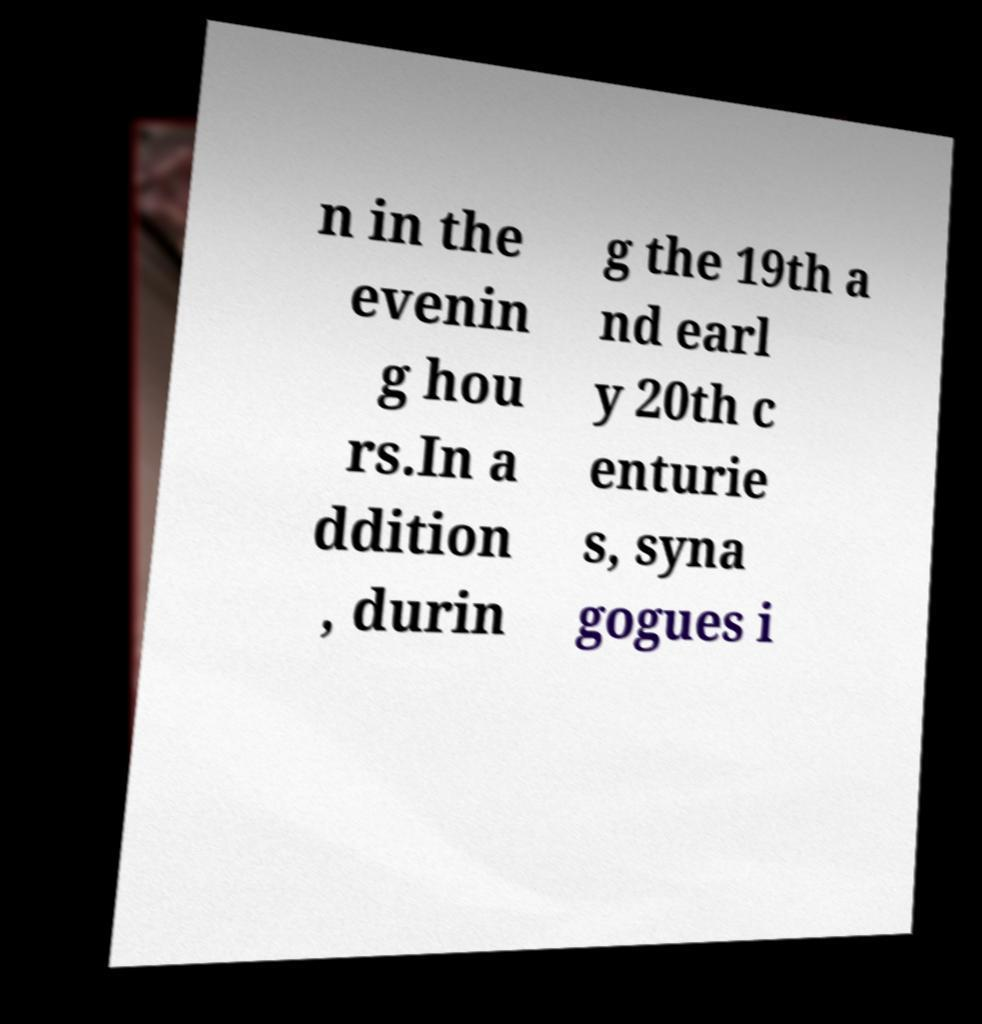Could you assist in decoding the text presented in this image and type it out clearly? n in the evenin g hou rs.In a ddition , durin g the 19th a nd earl y 20th c enturie s, syna gogues i 